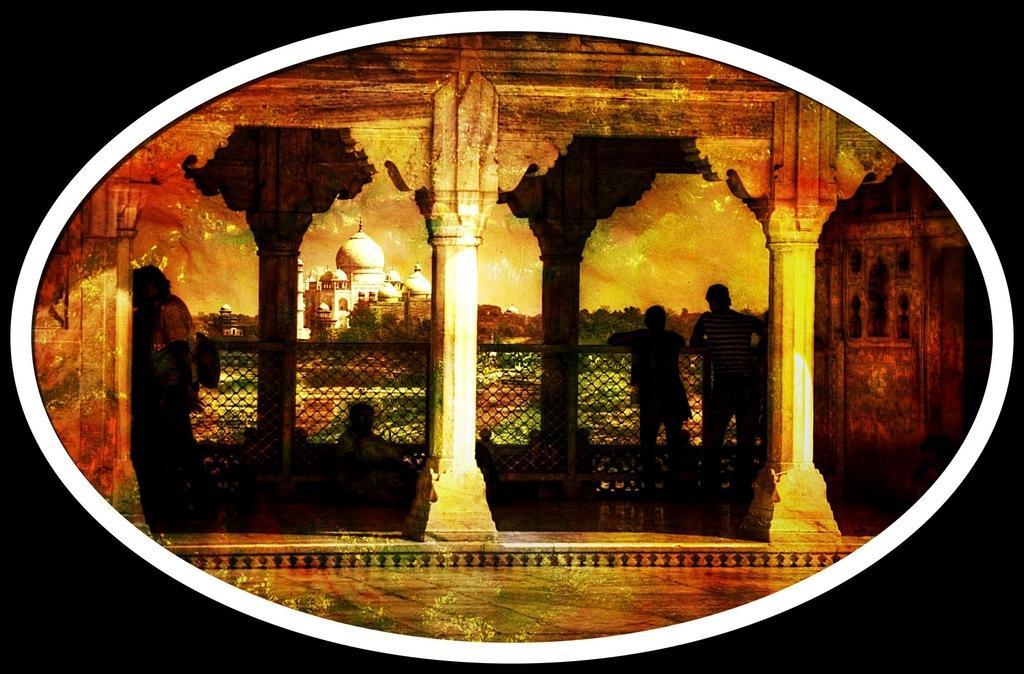Can you describe this image briefly? This is an edited image. I can see three persons standing and a person sitting on the floor. There are pillars and fence. In the background, I can see Taj Mahal, trees and there is the sky. 